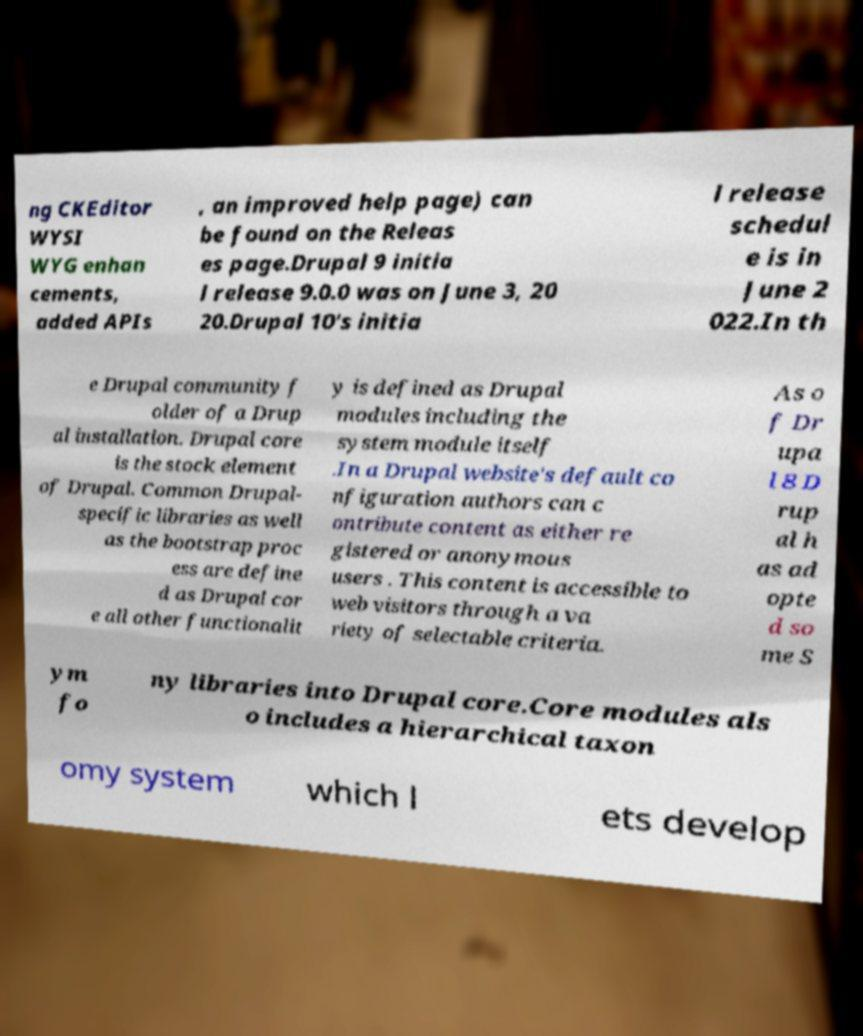Can you read and provide the text displayed in the image?This photo seems to have some interesting text. Can you extract and type it out for me? ng CKEditor WYSI WYG enhan cements, added APIs , an improved help page) can be found on the Releas es page.Drupal 9 initia l release 9.0.0 was on June 3, 20 20.Drupal 10's initia l release schedul e is in June 2 022.In th e Drupal community f older of a Drup al installation. Drupal core is the stock element of Drupal. Common Drupal- specific libraries as well as the bootstrap proc ess are define d as Drupal cor e all other functionalit y is defined as Drupal modules including the system module itself .In a Drupal website's default co nfiguration authors can c ontribute content as either re gistered or anonymous users . This content is accessible to web visitors through a va riety of selectable criteria. As o f Dr upa l 8 D rup al h as ad opte d so me S ym fo ny libraries into Drupal core.Core modules als o includes a hierarchical taxon omy system which l ets develop 